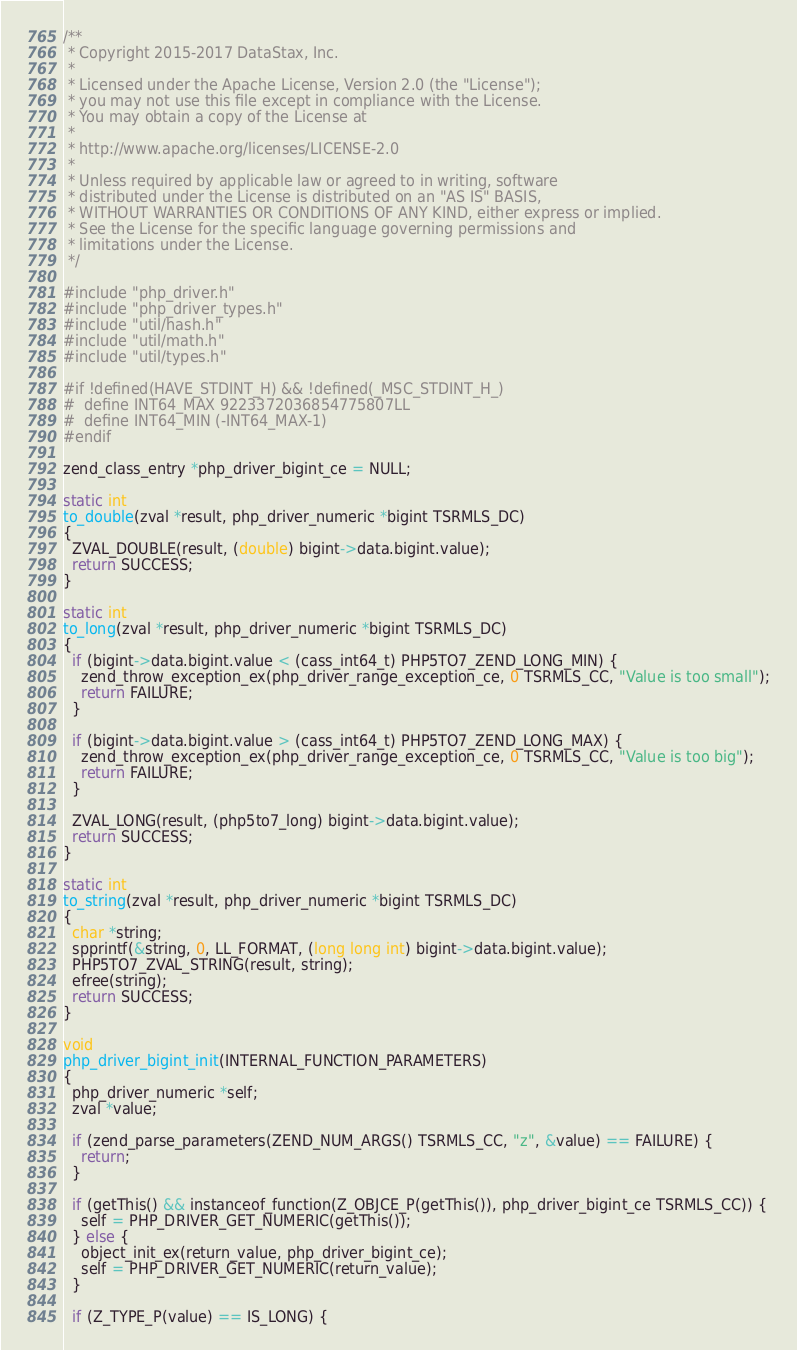Convert code to text. <code><loc_0><loc_0><loc_500><loc_500><_C_>/**
 * Copyright 2015-2017 DataStax, Inc.
 *
 * Licensed under the Apache License, Version 2.0 (the "License");
 * you may not use this file except in compliance with the License.
 * You may obtain a copy of the License at
 *
 * http://www.apache.org/licenses/LICENSE-2.0
 *
 * Unless required by applicable law or agreed to in writing, software
 * distributed under the License is distributed on an "AS IS" BASIS,
 * WITHOUT WARRANTIES OR CONDITIONS OF ANY KIND, either express or implied.
 * See the License for the specific language governing permissions and
 * limitations under the License.
 */

#include "php_driver.h"
#include "php_driver_types.h"
#include "util/hash.h"
#include "util/math.h"
#include "util/types.h"

#if !defined(HAVE_STDINT_H) && !defined(_MSC_STDINT_H_)
#  define INT64_MAX 9223372036854775807LL
#  define INT64_MIN (-INT64_MAX-1)
#endif

zend_class_entry *php_driver_bigint_ce = NULL;

static int
to_double(zval *result, php_driver_numeric *bigint TSRMLS_DC)
{
  ZVAL_DOUBLE(result, (double) bigint->data.bigint.value);
  return SUCCESS;
}

static int
to_long(zval *result, php_driver_numeric *bigint TSRMLS_DC)
{
  if (bigint->data.bigint.value < (cass_int64_t) PHP5TO7_ZEND_LONG_MIN) {
    zend_throw_exception_ex(php_driver_range_exception_ce, 0 TSRMLS_CC, "Value is too small");
    return FAILURE;
  }

  if (bigint->data.bigint.value > (cass_int64_t) PHP5TO7_ZEND_LONG_MAX) {
    zend_throw_exception_ex(php_driver_range_exception_ce, 0 TSRMLS_CC, "Value is too big");
    return FAILURE;
  }

  ZVAL_LONG(result, (php5to7_long) bigint->data.bigint.value);
  return SUCCESS;
}

static int
to_string(zval *result, php_driver_numeric *bigint TSRMLS_DC)
{
  char *string;
  spprintf(&string, 0, LL_FORMAT, (long long int) bigint->data.bigint.value);
  PHP5TO7_ZVAL_STRING(result, string);
  efree(string);
  return SUCCESS;
}

void
php_driver_bigint_init(INTERNAL_FUNCTION_PARAMETERS)
{
  php_driver_numeric *self;
  zval *value;

  if (zend_parse_parameters(ZEND_NUM_ARGS() TSRMLS_CC, "z", &value) == FAILURE) {
    return;
  }

  if (getThis() && instanceof_function(Z_OBJCE_P(getThis()), php_driver_bigint_ce TSRMLS_CC)) {
    self = PHP_DRIVER_GET_NUMERIC(getThis());
  } else {
    object_init_ex(return_value, php_driver_bigint_ce);
    self = PHP_DRIVER_GET_NUMERIC(return_value);
  }

  if (Z_TYPE_P(value) == IS_LONG) {</code> 